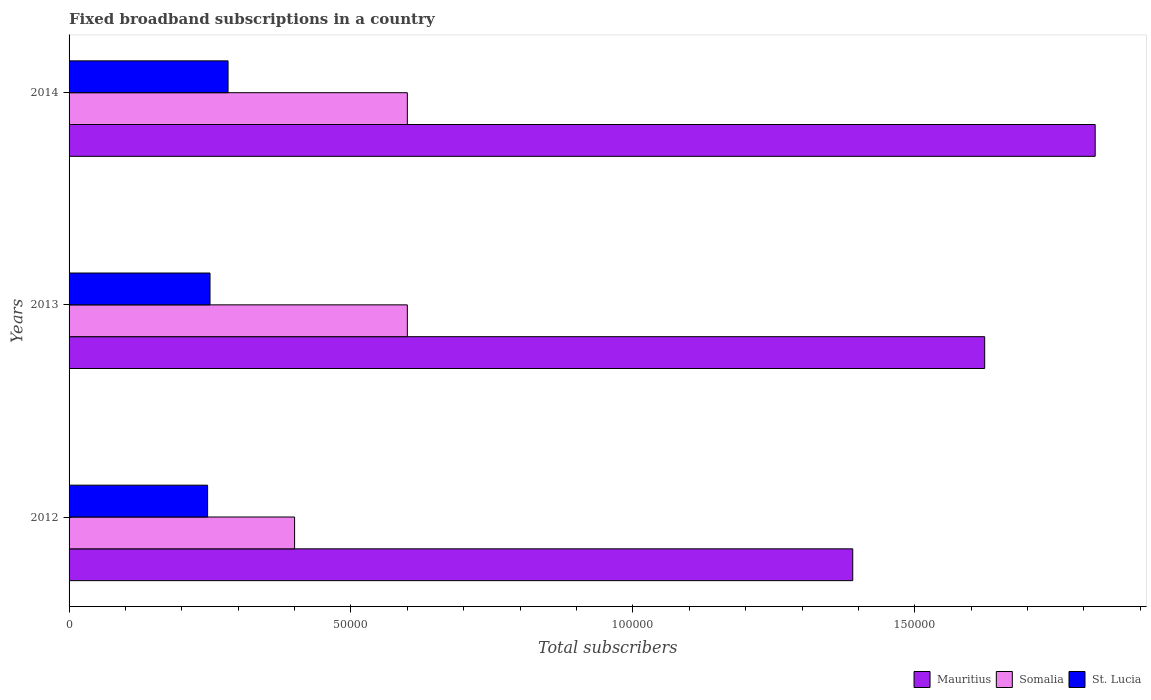How many groups of bars are there?
Your answer should be very brief. 3. Are the number of bars per tick equal to the number of legend labels?
Keep it short and to the point. Yes. Are the number of bars on each tick of the Y-axis equal?
Keep it short and to the point. Yes. How many bars are there on the 2nd tick from the top?
Your answer should be compact. 3. What is the label of the 2nd group of bars from the top?
Your answer should be very brief. 2013. What is the number of broadband subscriptions in St. Lucia in 2014?
Your answer should be very brief. 2.82e+04. Across all years, what is the maximum number of broadband subscriptions in St. Lucia?
Offer a very short reply. 2.82e+04. Across all years, what is the minimum number of broadband subscriptions in Somalia?
Make the answer very short. 4.00e+04. In which year was the number of broadband subscriptions in St. Lucia minimum?
Provide a short and direct response. 2012. What is the total number of broadband subscriptions in St. Lucia in the graph?
Keep it short and to the point. 7.78e+04. What is the difference between the number of broadband subscriptions in Mauritius in 2013 and that in 2014?
Your answer should be very brief. -1.96e+04. What is the difference between the number of broadband subscriptions in Mauritius in 2014 and the number of broadband subscriptions in Somalia in 2013?
Your answer should be compact. 1.22e+05. What is the average number of broadband subscriptions in St. Lucia per year?
Keep it short and to the point. 2.59e+04. In the year 2014, what is the difference between the number of broadband subscriptions in Mauritius and number of broadband subscriptions in Somalia?
Offer a very short reply. 1.22e+05. What is the ratio of the number of broadband subscriptions in Mauritius in 2013 to that in 2014?
Your response must be concise. 0.89. What is the difference between the highest and the second highest number of broadband subscriptions in St. Lucia?
Provide a short and direct response. 3200. What is the difference between the highest and the lowest number of broadband subscriptions in Mauritius?
Offer a terse response. 4.30e+04. Is the sum of the number of broadband subscriptions in Mauritius in 2012 and 2014 greater than the maximum number of broadband subscriptions in St. Lucia across all years?
Offer a terse response. Yes. What does the 3rd bar from the top in 2013 represents?
Provide a succinct answer. Mauritius. What does the 2nd bar from the bottom in 2013 represents?
Provide a succinct answer. Somalia. How many years are there in the graph?
Offer a very short reply. 3. What is the difference between two consecutive major ticks on the X-axis?
Your response must be concise. 5.00e+04. Are the values on the major ticks of X-axis written in scientific E-notation?
Offer a terse response. No. Where does the legend appear in the graph?
Your answer should be compact. Bottom right. How many legend labels are there?
Offer a terse response. 3. How are the legend labels stacked?
Ensure brevity in your answer.  Horizontal. What is the title of the graph?
Provide a succinct answer. Fixed broadband subscriptions in a country. What is the label or title of the X-axis?
Your answer should be very brief. Total subscribers. What is the Total subscribers in Mauritius in 2012?
Offer a terse response. 1.39e+05. What is the Total subscribers of St. Lucia in 2012?
Your answer should be compact. 2.46e+04. What is the Total subscribers of Mauritius in 2013?
Make the answer very short. 1.62e+05. What is the Total subscribers in Somalia in 2013?
Offer a terse response. 6.00e+04. What is the Total subscribers of St. Lucia in 2013?
Keep it short and to the point. 2.50e+04. What is the Total subscribers in Mauritius in 2014?
Offer a very short reply. 1.82e+05. What is the Total subscribers of Somalia in 2014?
Make the answer very short. 6.00e+04. What is the Total subscribers of St. Lucia in 2014?
Provide a short and direct response. 2.82e+04. Across all years, what is the maximum Total subscribers of Mauritius?
Ensure brevity in your answer.  1.82e+05. Across all years, what is the maximum Total subscribers of St. Lucia?
Provide a succinct answer. 2.82e+04. Across all years, what is the minimum Total subscribers in Mauritius?
Keep it short and to the point. 1.39e+05. Across all years, what is the minimum Total subscribers in Somalia?
Your response must be concise. 4.00e+04. Across all years, what is the minimum Total subscribers of St. Lucia?
Your response must be concise. 2.46e+04. What is the total Total subscribers in Mauritius in the graph?
Provide a succinct answer. 4.83e+05. What is the total Total subscribers of Somalia in the graph?
Offer a terse response. 1.60e+05. What is the total Total subscribers in St. Lucia in the graph?
Give a very brief answer. 7.78e+04. What is the difference between the Total subscribers in Mauritius in 2012 and that in 2013?
Offer a terse response. -2.34e+04. What is the difference between the Total subscribers in St. Lucia in 2012 and that in 2013?
Provide a short and direct response. -427. What is the difference between the Total subscribers in Mauritius in 2012 and that in 2014?
Offer a very short reply. -4.30e+04. What is the difference between the Total subscribers of Somalia in 2012 and that in 2014?
Offer a terse response. -2.00e+04. What is the difference between the Total subscribers of St. Lucia in 2012 and that in 2014?
Offer a terse response. -3627. What is the difference between the Total subscribers of Mauritius in 2013 and that in 2014?
Provide a short and direct response. -1.96e+04. What is the difference between the Total subscribers of Somalia in 2013 and that in 2014?
Your response must be concise. 0. What is the difference between the Total subscribers in St. Lucia in 2013 and that in 2014?
Keep it short and to the point. -3200. What is the difference between the Total subscribers of Mauritius in 2012 and the Total subscribers of Somalia in 2013?
Offer a terse response. 7.90e+04. What is the difference between the Total subscribers in Mauritius in 2012 and the Total subscribers in St. Lucia in 2013?
Your response must be concise. 1.14e+05. What is the difference between the Total subscribers of Somalia in 2012 and the Total subscribers of St. Lucia in 2013?
Offer a very short reply. 1.50e+04. What is the difference between the Total subscribers in Mauritius in 2012 and the Total subscribers in Somalia in 2014?
Your answer should be compact. 7.90e+04. What is the difference between the Total subscribers in Mauritius in 2012 and the Total subscribers in St. Lucia in 2014?
Provide a succinct answer. 1.11e+05. What is the difference between the Total subscribers of Somalia in 2012 and the Total subscribers of St. Lucia in 2014?
Ensure brevity in your answer.  1.18e+04. What is the difference between the Total subscribers of Mauritius in 2013 and the Total subscribers of Somalia in 2014?
Your answer should be compact. 1.02e+05. What is the difference between the Total subscribers in Mauritius in 2013 and the Total subscribers in St. Lucia in 2014?
Give a very brief answer. 1.34e+05. What is the difference between the Total subscribers in Somalia in 2013 and the Total subscribers in St. Lucia in 2014?
Keep it short and to the point. 3.18e+04. What is the average Total subscribers of Mauritius per year?
Offer a terse response. 1.61e+05. What is the average Total subscribers in Somalia per year?
Offer a very short reply. 5.33e+04. What is the average Total subscribers in St. Lucia per year?
Keep it short and to the point. 2.59e+04. In the year 2012, what is the difference between the Total subscribers of Mauritius and Total subscribers of Somalia?
Offer a very short reply. 9.90e+04. In the year 2012, what is the difference between the Total subscribers of Mauritius and Total subscribers of St. Lucia?
Offer a terse response. 1.14e+05. In the year 2012, what is the difference between the Total subscribers of Somalia and Total subscribers of St. Lucia?
Your answer should be very brief. 1.54e+04. In the year 2013, what is the difference between the Total subscribers in Mauritius and Total subscribers in Somalia?
Offer a terse response. 1.02e+05. In the year 2013, what is the difference between the Total subscribers in Mauritius and Total subscribers in St. Lucia?
Offer a very short reply. 1.37e+05. In the year 2013, what is the difference between the Total subscribers in Somalia and Total subscribers in St. Lucia?
Make the answer very short. 3.50e+04. In the year 2014, what is the difference between the Total subscribers in Mauritius and Total subscribers in Somalia?
Your answer should be very brief. 1.22e+05. In the year 2014, what is the difference between the Total subscribers in Mauritius and Total subscribers in St. Lucia?
Ensure brevity in your answer.  1.54e+05. In the year 2014, what is the difference between the Total subscribers in Somalia and Total subscribers in St. Lucia?
Your answer should be very brief. 3.18e+04. What is the ratio of the Total subscribers of Mauritius in 2012 to that in 2013?
Your answer should be very brief. 0.86. What is the ratio of the Total subscribers in Somalia in 2012 to that in 2013?
Provide a short and direct response. 0.67. What is the ratio of the Total subscribers in St. Lucia in 2012 to that in 2013?
Provide a succinct answer. 0.98. What is the ratio of the Total subscribers in Mauritius in 2012 to that in 2014?
Your answer should be compact. 0.76. What is the ratio of the Total subscribers of St. Lucia in 2012 to that in 2014?
Your answer should be compact. 0.87. What is the ratio of the Total subscribers of Mauritius in 2013 to that in 2014?
Give a very brief answer. 0.89. What is the ratio of the Total subscribers of St. Lucia in 2013 to that in 2014?
Offer a very short reply. 0.89. What is the difference between the highest and the second highest Total subscribers of Mauritius?
Ensure brevity in your answer.  1.96e+04. What is the difference between the highest and the second highest Total subscribers of Somalia?
Offer a terse response. 0. What is the difference between the highest and the second highest Total subscribers of St. Lucia?
Ensure brevity in your answer.  3200. What is the difference between the highest and the lowest Total subscribers of Mauritius?
Provide a short and direct response. 4.30e+04. What is the difference between the highest and the lowest Total subscribers in St. Lucia?
Your response must be concise. 3627. 